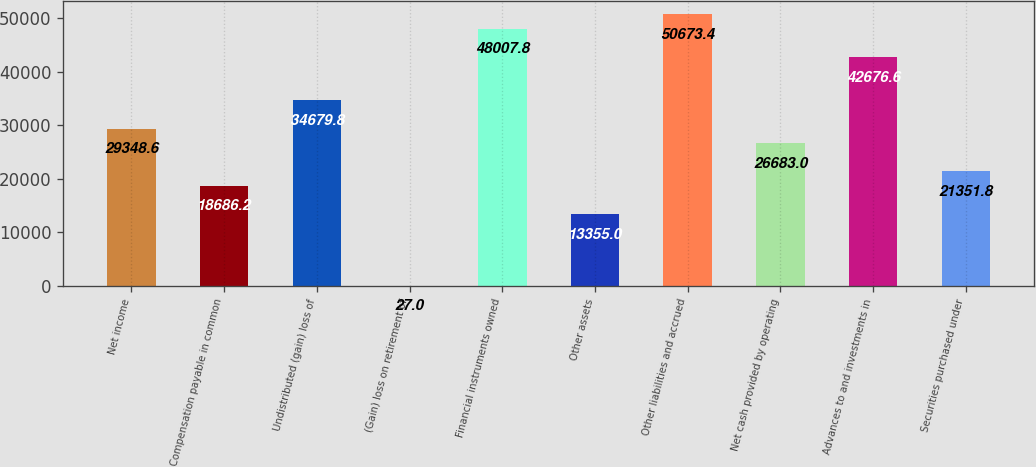Convert chart. <chart><loc_0><loc_0><loc_500><loc_500><bar_chart><fcel>Net income<fcel>Compensation payable in common<fcel>Undistributed (gain) loss of<fcel>(Gain) loss on retirement of<fcel>Financial instruments owned<fcel>Other assets<fcel>Other liabilities and accrued<fcel>Net cash provided by operating<fcel>Advances to and investments in<fcel>Securities purchased under<nl><fcel>29348.6<fcel>18686.2<fcel>34679.8<fcel>27<fcel>48007.8<fcel>13355<fcel>50673.4<fcel>26683<fcel>42676.6<fcel>21351.8<nl></chart> 